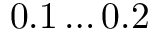<formula> <loc_0><loc_0><loc_500><loc_500>0 . 1 \dots 0 . 2 \</formula> 